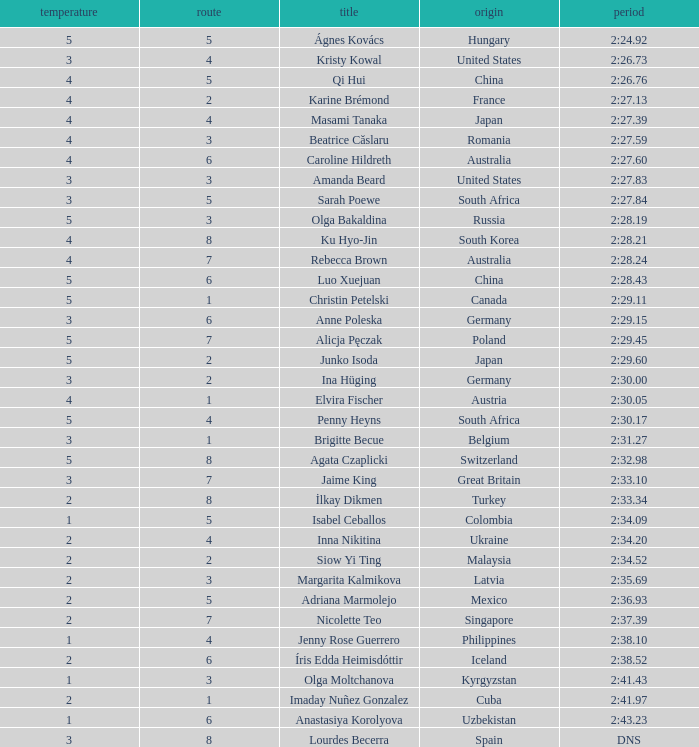What course did inna nikitina pursue? 4.0. 